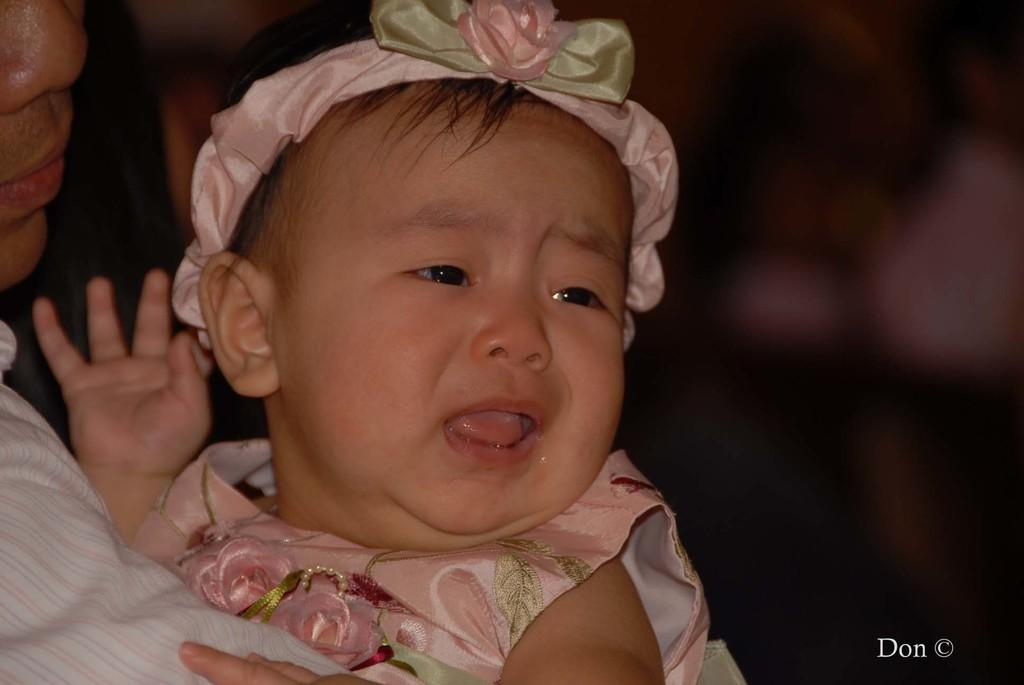What is the main subject of the image? The main subject of the image is a baby. Can you describe the baby's attire? The baby is wearing a colorful dress and a colorful band. What is the baby doing in the image? The baby is crying. Who is holding the baby in the image? There is a person holding the baby on the left side of the image. What can be seen on the right side of the image? There is a dark view on the right side of the image. What type of pear is being used as a border in the image? There is no pear or border present in the image. What kind of paper is visible on the baby's dress? The baby's dress is made of fabric, not paper. 